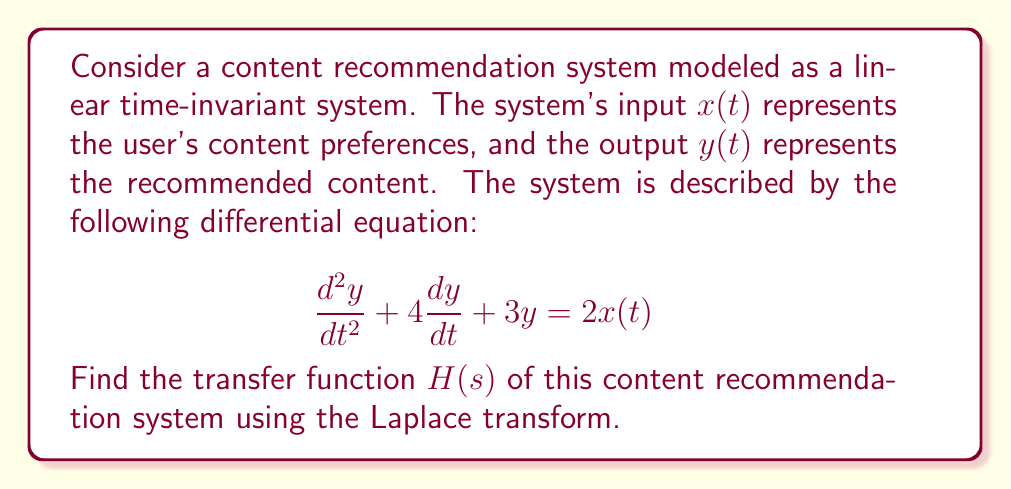Give your solution to this math problem. To find the transfer function $H(s)$, we need to apply the Laplace transform to both sides of the differential equation and then solve for the ratio of the output to the input in the s-domain.

1. Apply the Laplace transform to both sides of the equation:
   $$\mathcal{L}\left\{\frac{d^2y}{dt^2} + 4\frac{dy}{dt} + 3y\right\} = \mathcal{L}\{2x(t)\}$$

2. Use the properties of the Laplace transform:
   $$(s^2Y(s) - sy(0) - y'(0)) + 4(sY(s) - y(0)) + 3Y(s) = 2X(s)$$

3. Assume zero initial conditions (y(0) = 0 and y'(0) = 0):
   $$s^2Y(s) + 4sY(s) + 3Y(s) = 2X(s)$$

4. Factor out Y(s):
   $$Y(s)(s^2 + 4s + 3) = 2X(s)$$

5. Solve for Y(s):
   $$Y(s) = \frac{2X(s)}{s^2 + 4s + 3}$$

6. The transfer function H(s) is defined as the ratio of the output to the input in the s-domain:
   $$H(s) = \frac{Y(s)}{X(s)} = \frac{2}{s^2 + 4s + 3}$$

Thus, we have found the transfer function of the content recommendation system.
Answer: $$H(s) = \frac{2}{s^2 + 4s + 3}$$ 